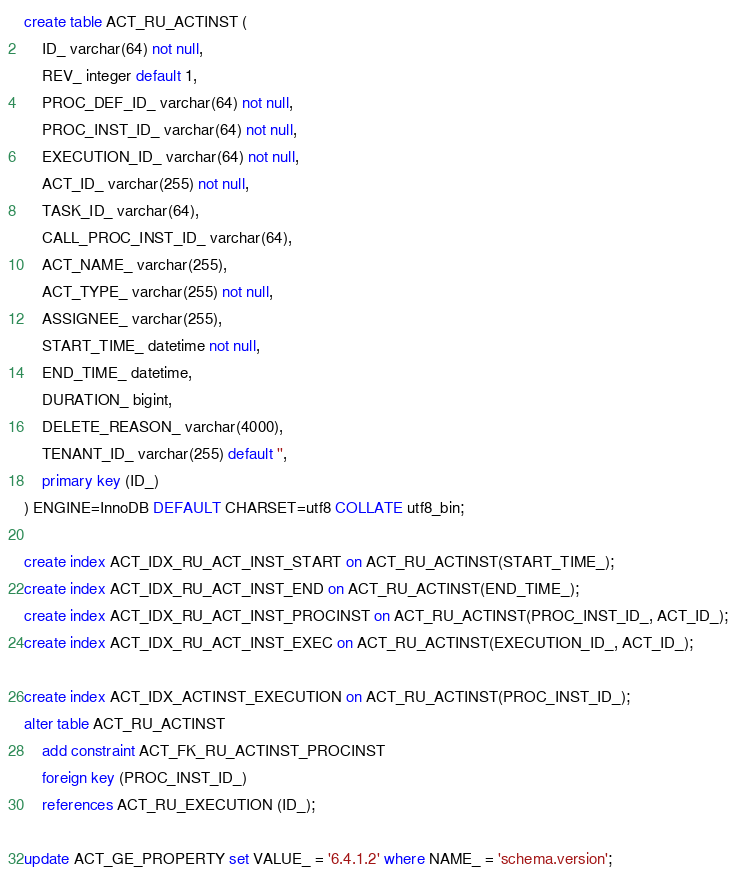Convert code to text. <code><loc_0><loc_0><loc_500><loc_500><_SQL_>create table ACT_RU_ACTINST (
    ID_ varchar(64) not null,
    REV_ integer default 1,
    PROC_DEF_ID_ varchar(64) not null,
    PROC_INST_ID_ varchar(64) not null,
    EXECUTION_ID_ varchar(64) not null,
    ACT_ID_ varchar(255) not null,
    TASK_ID_ varchar(64),
    CALL_PROC_INST_ID_ varchar(64),
    ACT_NAME_ varchar(255),
    ACT_TYPE_ varchar(255) not null,
    ASSIGNEE_ varchar(255),
    START_TIME_ datetime not null,
    END_TIME_ datetime,
    DURATION_ bigint,
    DELETE_REASON_ varchar(4000),
    TENANT_ID_ varchar(255) default '',
    primary key (ID_)
) ENGINE=InnoDB DEFAULT CHARSET=utf8 COLLATE utf8_bin;

create index ACT_IDX_RU_ACT_INST_START on ACT_RU_ACTINST(START_TIME_);
create index ACT_IDX_RU_ACT_INST_END on ACT_RU_ACTINST(END_TIME_);
create index ACT_IDX_RU_ACT_INST_PROCINST on ACT_RU_ACTINST(PROC_INST_ID_, ACT_ID_);
create index ACT_IDX_RU_ACT_INST_EXEC on ACT_RU_ACTINST(EXECUTION_ID_, ACT_ID_);

create index ACT_IDX_ACTINST_EXECUTION on ACT_RU_ACTINST(PROC_INST_ID_);
alter table ACT_RU_ACTINST
    add constraint ACT_FK_RU_ACTINST_PROCINST
    foreign key (PROC_INST_ID_)
    references ACT_RU_EXECUTION (ID_);

update ACT_GE_PROPERTY set VALUE_ = '6.4.1.2' where NAME_ = 'schema.version';
</code> 